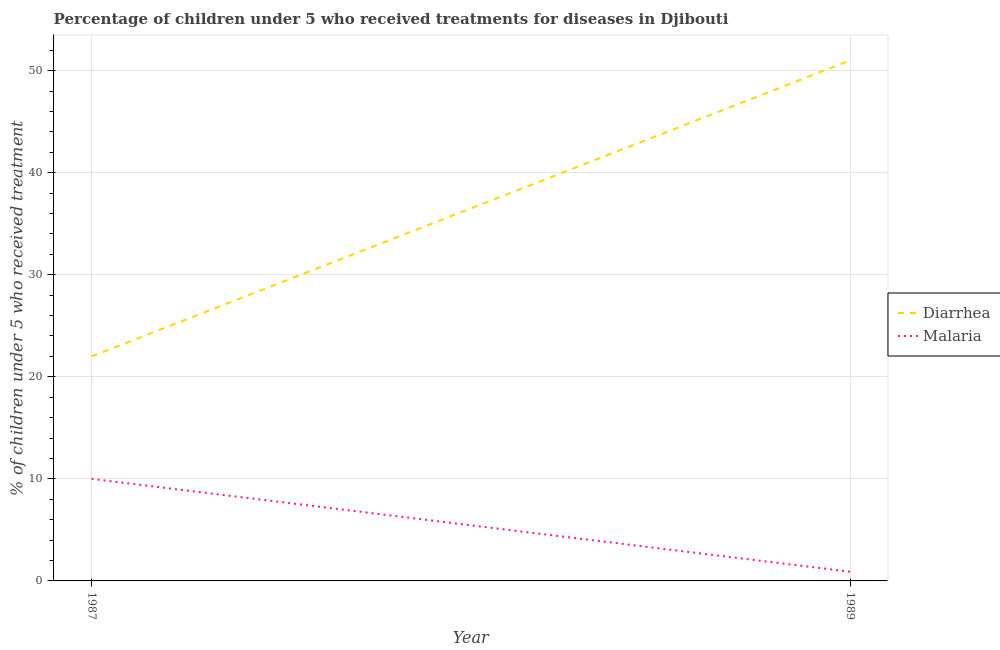Is the number of lines equal to the number of legend labels?
Keep it short and to the point. Yes. What is the percentage of children who received treatment for diarrhoea in 1989?
Give a very brief answer. 51. Across all years, what is the minimum percentage of children who received treatment for malaria?
Your answer should be compact. 0.9. In which year was the percentage of children who received treatment for malaria maximum?
Your response must be concise. 1987. In which year was the percentage of children who received treatment for diarrhoea minimum?
Ensure brevity in your answer.  1987. What is the total percentage of children who received treatment for diarrhoea in the graph?
Offer a terse response. 73. What is the difference between the percentage of children who received treatment for diarrhoea in 1987 and that in 1989?
Your answer should be very brief. -29. What is the difference between the percentage of children who received treatment for malaria in 1989 and the percentage of children who received treatment for diarrhoea in 1987?
Provide a short and direct response. -21.1. What is the average percentage of children who received treatment for diarrhoea per year?
Give a very brief answer. 36.5. In the year 1989, what is the difference between the percentage of children who received treatment for diarrhoea and percentage of children who received treatment for malaria?
Provide a short and direct response. 50.1. What is the ratio of the percentage of children who received treatment for diarrhoea in 1987 to that in 1989?
Provide a short and direct response. 0.43. Is the percentage of children who received treatment for malaria in 1987 less than that in 1989?
Give a very brief answer. No. In how many years, is the percentage of children who received treatment for diarrhoea greater than the average percentage of children who received treatment for diarrhoea taken over all years?
Ensure brevity in your answer.  1. Does the percentage of children who received treatment for malaria monotonically increase over the years?
Provide a short and direct response. No. Is the percentage of children who received treatment for diarrhoea strictly greater than the percentage of children who received treatment for malaria over the years?
Make the answer very short. Yes. Is the percentage of children who received treatment for malaria strictly less than the percentage of children who received treatment for diarrhoea over the years?
Your answer should be compact. Yes. How many lines are there?
Ensure brevity in your answer.  2. How are the legend labels stacked?
Your answer should be compact. Vertical. What is the title of the graph?
Provide a succinct answer. Percentage of children under 5 who received treatments for diseases in Djibouti. Does "Not attending school" appear as one of the legend labels in the graph?
Your answer should be compact. No. What is the label or title of the Y-axis?
Give a very brief answer. % of children under 5 who received treatment. What is the % of children under 5 who received treatment of Diarrhea in 1989?
Your response must be concise. 51. What is the % of children under 5 who received treatment in Malaria in 1989?
Your answer should be compact. 0.9. Across all years, what is the maximum % of children under 5 who received treatment of Malaria?
Your answer should be compact. 10. Across all years, what is the minimum % of children under 5 who received treatment of Diarrhea?
Provide a succinct answer. 22. Across all years, what is the minimum % of children under 5 who received treatment of Malaria?
Provide a short and direct response. 0.9. What is the difference between the % of children under 5 who received treatment of Malaria in 1987 and that in 1989?
Your answer should be very brief. 9.1. What is the difference between the % of children under 5 who received treatment in Diarrhea in 1987 and the % of children under 5 who received treatment in Malaria in 1989?
Offer a very short reply. 21.1. What is the average % of children under 5 who received treatment in Diarrhea per year?
Provide a succinct answer. 36.5. What is the average % of children under 5 who received treatment of Malaria per year?
Offer a terse response. 5.45. In the year 1989, what is the difference between the % of children under 5 who received treatment in Diarrhea and % of children under 5 who received treatment in Malaria?
Offer a terse response. 50.1. What is the ratio of the % of children under 5 who received treatment of Diarrhea in 1987 to that in 1989?
Provide a succinct answer. 0.43. What is the ratio of the % of children under 5 who received treatment of Malaria in 1987 to that in 1989?
Keep it short and to the point. 11.11. What is the difference between the highest and the second highest % of children under 5 who received treatment in Diarrhea?
Offer a very short reply. 29. 